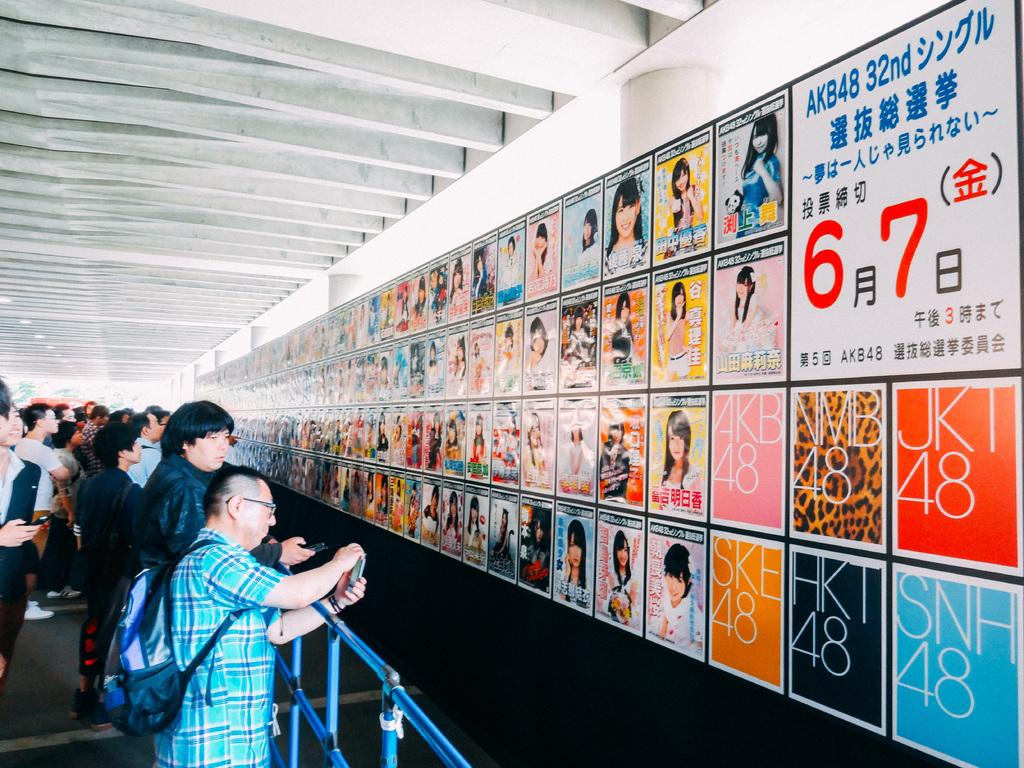What is on the poster in the image? The poster has photos, numbers, and letters in the image. Where is the poster located? The poster is on a wall. What can be seen in the background of the image? There is a group of people standing and iron rods and lights are visible in the background of the image. What type of fowl can be seen playing with paste at the seashore in the image? There is no fowl or paste present at the seashore in the image, as the image does not depict a seashore or any fowl. 